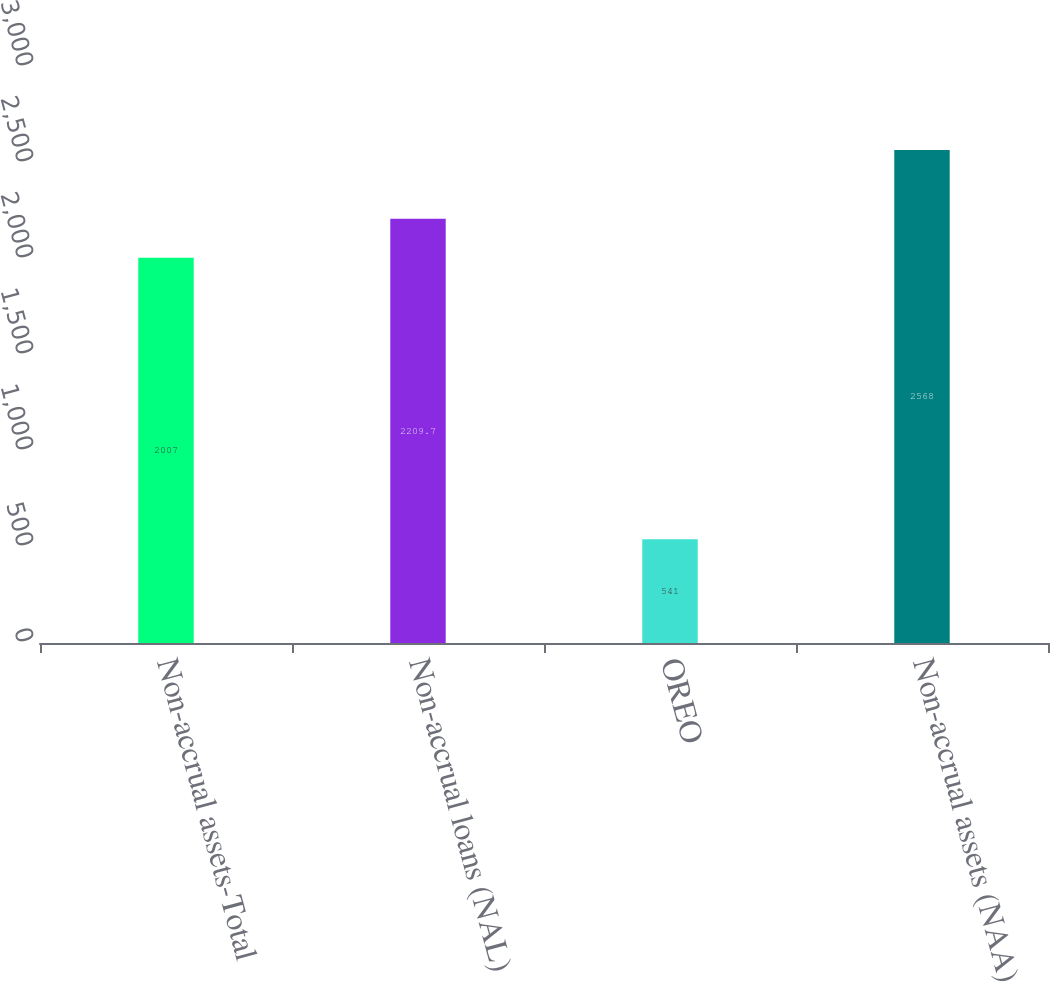Convert chart. <chart><loc_0><loc_0><loc_500><loc_500><bar_chart><fcel>Non-accrual assets-Total<fcel>Non-accrual loans (NAL)<fcel>OREO<fcel>Non-accrual assets (NAA)<nl><fcel>2007<fcel>2209.7<fcel>541<fcel>2568<nl></chart> 